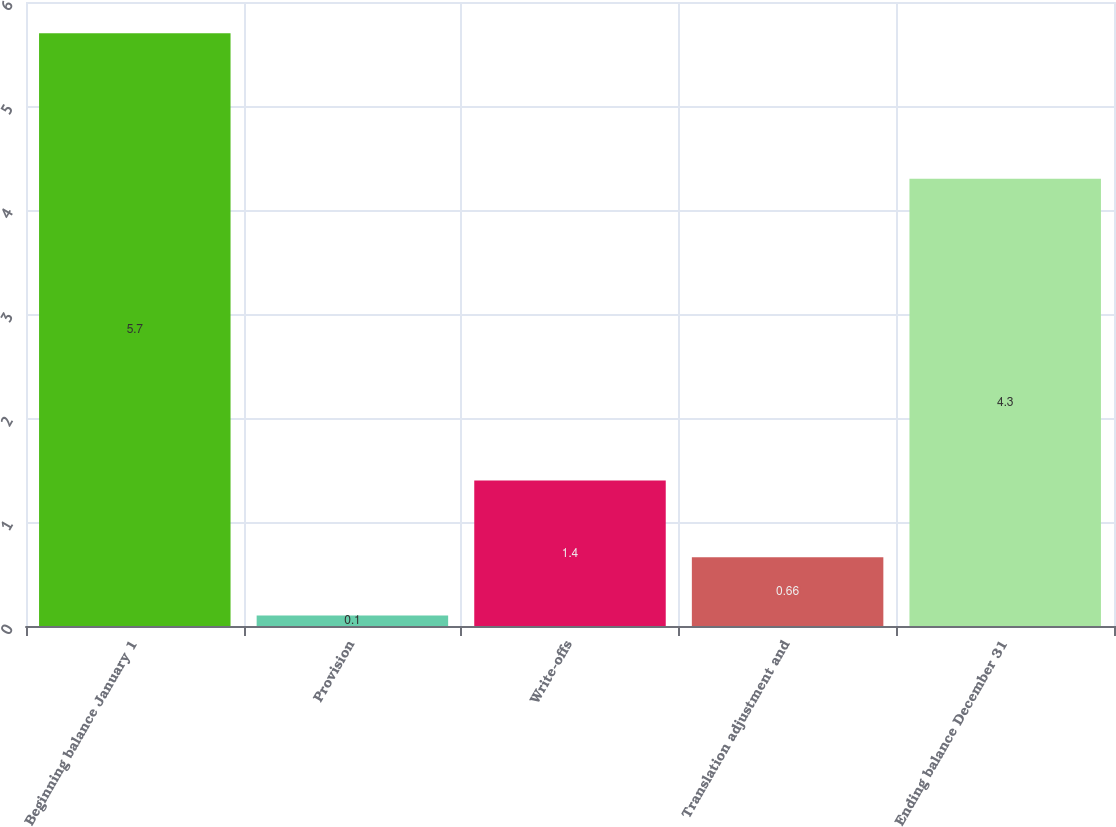<chart> <loc_0><loc_0><loc_500><loc_500><bar_chart><fcel>Beginning balance January 1<fcel>Provision<fcel>Write-offs<fcel>Translation adjustment and<fcel>Ending balance December 31<nl><fcel>5.7<fcel>0.1<fcel>1.4<fcel>0.66<fcel>4.3<nl></chart> 